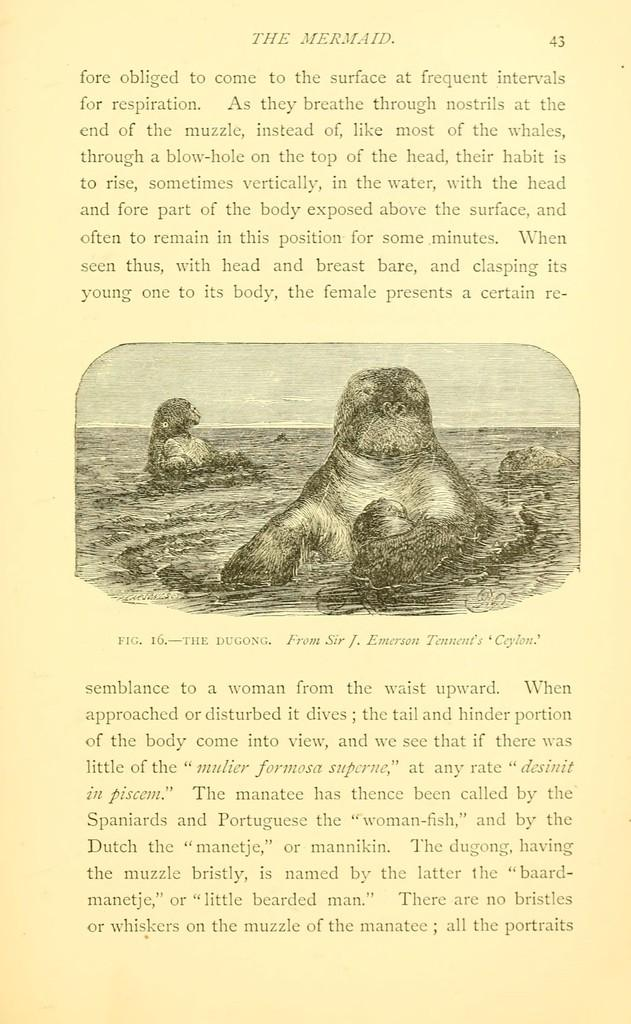What can be found on the poster in the image? There is text and an image on the poster. What is depicted in the image on the poster? The image contains two animals. Where are the animals located in the image? The animals are in the water. How many apples are being held by the animals in the image? There are no apples present in the image; the animals are in the water. What word is written on the poster in the image? The provided facts do not mention any specific words on the poster, so we cannot answer this question definitively. 